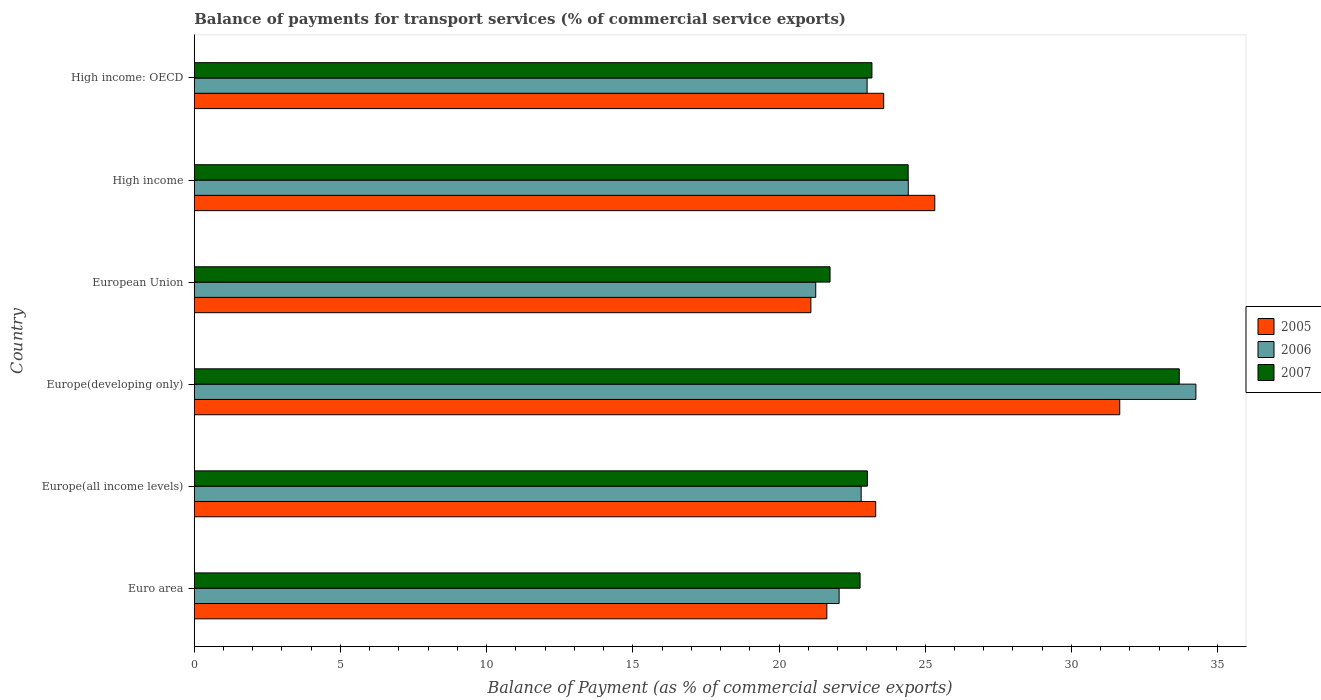How many different coloured bars are there?
Make the answer very short. 3. How many bars are there on the 4th tick from the bottom?
Offer a terse response. 3. What is the balance of payments for transport services in 2006 in High income: OECD?
Provide a short and direct response. 23.01. Across all countries, what is the maximum balance of payments for transport services in 2005?
Your response must be concise. 31.65. Across all countries, what is the minimum balance of payments for transport services in 2005?
Ensure brevity in your answer.  21.09. In which country was the balance of payments for transport services in 2005 maximum?
Your answer should be very brief. Europe(developing only). In which country was the balance of payments for transport services in 2007 minimum?
Keep it short and to the point. European Union. What is the total balance of payments for transport services in 2005 in the graph?
Offer a very short reply. 146.59. What is the difference between the balance of payments for transport services in 2006 in Euro area and that in High income?
Provide a short and direct response. -2.37. What is the difference between the balance of payments for transport services in 2006 in Euro area and the balance of payments for transport services in 2007 in Europe(all income levels)?
Offer a very short reply. -0.97. What is the average balance of payments for transport services in 2007 per country?
Keep it short and to the point. 24.8. What is the difference between the balance of payments for transport services in 2005 and balance of payments for transport services in 2006 in European Union?
Provide a short and direct response. -0.17. What is the ratio of the balance of payments for transport services in 2006 in Europe(all income levels) to that in High income?
Keep it short and to the point. 0.93. Is the balance of payments for transport services in 2005 in Europe(developing only) less than that in European Union?
Offer a very short reply. No. Is the difference between the balance of payments for transport services in 2005 in European Union and High income: OECD greater than the difference between the balance of payments for transport services in 2006 in European Union and High income: OECD?
Your answer should be compact. No. What is the difference between the highest and the second highest balance of payments for transport services in 2007?
Give a very brief answer. 9.27. What is the difference between the highest and the lowest balance of payments for transport services in 2006?
Offer a terse response. 13. Is the sum of the balance of payments for transport services in 2007 in Europe(all income levels) and High income greater than the maximum balance of payments for transport services in 2006 across all countries?
Your answer should be very brief. Yes. What does the 2nd bar from the top in High income represents?
Offer a terse response. 2006. What does the 1st bar from the bottom in European Union represents?
Provide a succinct answer. 2005. Is it the case that in every country, the sum of the balance of payments for transport services in 2006 and balance of payments for transport services in 2007 is greater than the balance of payments for transport services in 2005?
Offer a very short reply. Yes. How many bars are there?
Offer a very short reply. 18. How many countries are there in the graph?
Offer a terse response. 6. Does the graph contain grids?
Your answer should be very brief. No. Where does the legend appear in the graph?
Offer a terse response. Center right. What is the title of the graph?
Offer a very short reply. Balance of payments for transport services (% of commercial service exports). What is the label or title of the X-axis?
Make the answer very short. Balance of Payment (as % of commercial service exports). What is the Balance of Payment (as % of commercial service exports) of 2005 in Euro area?
Your answer should be very brief. 21.64. What is the Balance of Payment (as % of commercial service exports) of 2006 in Euro area?
Keep it short and to the point. 22.06. What is the Balance of Payment (as % of commercial service exports) in 2007 in Euro area?
Give a very brief answer. 22.77. What is the Balance of Payment (as % of commercial service exports) of 2005 in Europe(all income levels)?
Make the answer very short. 23.31. What is the Balance of Payment (as % of commercial service exports) of 2006 in Europe(all income levels)?
Make the answer very short. 22.81. What is the Balance of Payment (as % of commercial service exports) of 2007 in Europe(all income levels)?
Your answer should be compact. 23.02. What is the Balance of Payment (as % of commercial service exports) of 2005 in Europe(developing only)?
Offer a terse response. 31.65. What is the Balance of Payment (as % of commercial service exports) of 2006 in Europe(developing only)?
Provide a succinct answer. 34.26. What is the Balance of Payment (as % of commercial service exports) in 2007 in Europe(developing only)?
Ensure brevity in your answer.  33.69. What is the Balance of Payment (as % of commercial service exports) of 2005 in European Union?
Ensure brevity in your answer.  21.09. What is the Balance of Payment (as % of commercial service exports) of 2006 in European Union?
Give a very brief answer. 21.25. What is the Balance of Payment (as % of commercial service exports) in 2007 in European Union?
Provide a short and direct response. 21.74. What is the Balance of Payment (as % of commercial service exports) of 2005 in High income?
Your response must be concise. 25.33. What is the Balance of Payment (as % of commercial service exports) of 2006 in High income?
Provide a succinct answer. 24.42. What is the Balance of Payment (as % of commercial service exports) of 2007 in High income?
Give a very brief answer. 24.42. What is the Balance of Payment (as % of commercial service exports) of 2005 in High income: OECD?
Keep it short and to the point. 23.58. What is the Balance of Payment (as % of commercial service exports) of 2006 in High income: OECD?
Keep it short and to the point. 23.01. What is the Balance of Payment (as % of commercial service exports) of 2007 in High income: OECD?
Your answer should be very brief. 23.18. Across all countries, what is the maximum Balance of Payment (as % of commercial service exports) of 2005?
Ensure brevity in your answer.  31.65. Across all countries, what is the maximum Balance of Payment (as % of commercial service exports) in 2006?
Your answer should be compact. 34.26. Across all countries, what is the maximum Balance of Payment (as % of commercial service exports) of 2007?
Offer a terse response. 33.69. Across all countries, what is the minimum Balance of Payment (as % of commercial service exports) of 2005?
Make the answer very short. 21.09. Across all countries, what is the minimum Balance of Payment (as % of commercial service exports) of 2006?
Give a very brief answer. 21.25. Across all countries, what is the minimum Balance of Payment (as % of commercial service exports) of 2007?
Make the answer very short. 21.74. What is the total Balance of Payment (as % of commercial service exports) of 2005 in the graph?
Your answer should be compact. 146.59. What is the total Balance of Payment (as % of commercial service exports) of 2006 in the graph?
Your response must be concise. 147.81. What is the total Balance of Payment (as % of commercial service exports) in 2007 in the graph?
Ensure brevity in your answer.  148.82. What is the difference between the Balance of Payment (as % of commercial service exports) of 2005 in Euro area and that in Europe(all income levels)?
Ensure brevity in your answer.  -1.67. What is the difference between the Balance of Payment (as % of commercial service exports) in 2006 in Euro area and that in Europe(all income levels)?
Provide a short and direct response. -0.75. What is the difference between the Balance of Payment (as % of commercial service exports) of 2007 in Euro area and that in Europe(all income levels)?
Your response must be concise. -0.25. What is the difference between the Balance of Payment (as % of commercial service exports) in 2005 in Euro area and that in Europe(developing only)?
Your answer should be very brief. -10.02. What is the difference between the Balance of Payment (as % of commercial service exports) of 2006 in Euro area and that in Europe(developing only)?
Provide a succinct answer. -12.2. What is the difference between the Balance of Payment (as % of commercial service exports) of 2007 in Euro area and that in Europe(developing only)?
Offer a very short reply. -10.92. What is the difference between the Balance of Payment (as % of commercial service exports) in 2005 in Euro area and that in European Union?
Provide a short and direct response. 0.55. What is the difference between the Balance of Payment (as % of commercial service exports) in 2006 in Euro area and that in European Union?
Give a very brief answer. 0.8. What is the difference between the Balance of Payment (as % of commercial service exports) in 2007 in Euro area and that in European Union?
Provide a short and direct response. 1.03. What is the difference between the Balance of Payment (as % of commercial service exports) in 2005 in Euro area and that in High income?
Give a very brief answer. -3.69. What is the difference between the Balance of Payment (as % of commercial service exports) in 2006 in Euro area and that in High income?
Provide a succinct answer. -2.37. What is the difference between the Balance of Payment (as % of commercial service exports) in 2007 in Euro area and that in High income?
Your response must be concise. -1.65. What is the difference between the Balance of Payment (as % of commercial service exports) in 2005 in Euro area and that in High income: OECD?
Make the answer very short. -1.94. What is the difference between the Balance of Payment (as % of commercial service exports) in 2006 in Euro area and that in High income: OECD?
Keep it short and to the point. -0.96. What is the difference between the Balance of Payment (as % of commercial service exports) in 2007 in Euro area and that in High income: OECD?
Your answer should be very brief. -0.41. What is the difference between the Balance of Payment (as % of commercial service exports) in 2005 in Europe(all income levels) and that in Europe(developing only)?
Make the answer very short. -8.35. What is the difference between the Balance of Payment (as % of commercial service exports) of 2006 in Europe(all income levels) and that in Europe(developing only)?
Keep it short and to the point. -11.45. What is the difference between the Balance of Payment (as % of commercial service exports) of 2007 in Europe(all income levels) and that in Europe(developing only)?
Your response must be concise. -10.67. What is the difference between the Balance of Payment (as % of commercial service exports) of 2005 in Europe(all income levels) and that in European Union?
Ensure brevity in your answer.  2.22. What is the difference between the Balance of Payment (as % of commercial service exports) of 2006 in Europe(all income levels) and that in European Union?
Ensure brevity in your answer.  1.55. What is the difference between the Balance of Payment (as % of commercial service exports) of 2007 in Europe(all income levels) and that in European Union?
Give a very brief answer. 1.28. What is the difference between the Balance of Payment (as % of commercial service exports) in 2005 in Europe(all income levels) and that in High income?
Ensure brevity in your answer.  -2.02. What is the difference between the Balance of Payment (as % of commercial service exports) in 2006 in Europe(all income levels) and that in High income?
Offer a terse response. -1.61. What is the difference between the Balance of Payment (as % of commercial service exports) of 2007 in Europe(all income levels) and that in High income?
Keep it short and to the point. -1.4. What is the difference between the Balance of Payment (as % of commercial service exports) of 2005 in Europe(all income levels) and that in High income: OECD?
Give a very brief answer. -0.27. What is the difference between the Balance of Payment (as % of commercial service exports) in 2006 in Europe(all income levels) and that in High income: OECD?
Offer a very short reply. -0.2. What is the difference between the Balance of Payment (as % of commercial service exports) of 2007 in Europe(all income levels) and that in High income: OECD?
Keep it short and to the point. -0.16. What is the difference between the Balance of Payment (as % of commercial service exports) in 2005 in Europe(developing only) and that in European Union?
Keep it short and to the point. 10.56. What is the difference between the Balance of Payment (as % of commercial service exports) of 2006 in Europe(developing only) and that in European Union?
Provide a succinct answer. 13. What is the difference between the Balance of Payment (as % of commercial service exports) in 2007 in Europe(developing only) and that in European Union?
Ensure brevity in your answer.  11.94. What is the difference between the Balance of Payment (as % of commercial service exports) in 2005 in Europe(developing only) and that in High income?
Make the answer very short. 6.33. What is the difference between the Balance of Payment (as % of commercial service exports) of 2006 in Europe(developing only) and that in High income?
Keep it short and to the point. 9.84. What is the difference between the Balance of Payment (as % of commercial service exports) of 2007 in Europe(developing only) and that in High income?
Give a very brief answer. 9.27. What is the difference between the Balance of Payment (as % of commercial service exports) in 2005 in Europe(developing only) and that in High income: OECD?
Make the answer very short. 8.07. What is the difference between the Balance of Payment (as % of commercial service exports) in 2006 in Europe(developing only) and that in High income: OECD?
Your answer should be very brief. 11.25. What is the difference between the Balance of Payment (as % of commercial service exports) of 2007 in Europe(developing only) and that in High income: OECD?
Offer a terse response. 10.51. What is the difference between the Balance of Payment (as % of commercial service exports) in 2005 in European Union and that in High income?
Offer a terse response. -4.24. What is the difference between the Balance of Payment (as % of commercial service exports) in 2006 in European Union and that in High income?
Your answer should be very brief. -3.17. What is the difference between the Balance of Payment (as % of commercial service exports) of 2007 in European Union and that in High income?
Your answer should be very brief. -2.67. What is the difference between the Balance of Payment (as % of commercial service exports) in 2005 in European Union and that in High income: OECD?
Give a very brief answer. -2.49. What is the difference between the Balance of Payment (as % of commercial service exports) of 2006 in European Union and that in High income: OECD?
Provide a succinct answer. -1.76. What is the difference between the Balance of Payment (as % of commercial service exports) in 2007 in European Union and that in High income: OECD?
Give a very brief answer. -1.43. What is the difference between the Balance of Payment (as % of commercial service exports) of 2005 in High income and that in High income: OECD?
Give a very brief answer. 1.75. What is the difference between the Balance of Payment (as % of commercial service exports) in 2006 in High income and that in High income: OECD?
Give a very brief answer. 1.41. What is the difference between the Balance of Payment (as % of commercial service exports) of 2007 in High income and that in High income: OECD?
Keep it short and to the point. 1.24. What is the difference between the Balance of Payment (as % of commercial service exports) in 2005 in Euro area and the Balance of Payment (as % of commercial service exports) in 2006 in Europe(all income levels)?
Ensure brevity in your answer.  -1.17. What is the difference between the Balance of Payment (as % of commercial service exports) of 2005 in Euro area and the Balance of Payment (as % of commercial service exports) of 2007 in Europe(all income levels)?
Keep it short and to the point. -1.39. What is the difference between the Balance of Payment (as % of commercial service exports) of 2006 in Euro area and the Balance of Payment (as % of commercial service exports) of 2007 in Europe(all income levels)?
Offer a terse response. -0.97. What is the difference between the Balance of Payment (as % of commercial service exports) in 2005 in Euro area and the Balance of Payment (as % of commercial service exports) in 2006 in Europe(developing only)?
Your response must be concise. -12.62. What is the difference between the Balance of Payment (as % of commercial service exports) in 2005 in Euro area and the Balance of Payment (as % of commercial service exports) in 2007 in Europe(developing only)?
Provide a succinct answer. -12.05. What is the difference between the Balance of Payment (as % of commercial service exports) in 2006 in Euro area and the Balance of Payment (as % of commercial service exports) in 2007 in Europe(developing only)?
Your answer should be very brief. -11.63. What is the difference between the Balance of Payment (as % of commercial service exports) of 2005 in Euro area and the Balance of Payment (as % of commercial service exports) of 2006 in European Union?
Keep it short and to the point. 0.38. What is the difference between the Balance of Payment (as % of commercial service exports) of 2005 in Euro area and the Balance of Payment (as % of commercial service exports) of 2007 in European Union?
Provide a short and direct response. -0.11. What is the difference between the Balance of Payment (as % of commercial service exports) of 2006 in Euro area and the Balance of Payment (as % of commercial service exports) of 2007 in European Union?
Keep it short and to the point. 0.31. What is the difference between the Balance of Payment (as % of commercial service exports) of 2005 in Euro area and the Balance of Payment (as % of commercial service exports) of 2006 in High income?
Provide a succinct answer. -2.79. What is the difference between the Balance of Payment (as % of commercial service exports) in 2005 in Euro area and the Balance of Payment (as % of commercial service exports) in 2007 in High income?
Provide a short and direct response. -2.78. What is the difference between the Balance of Payment (as % of commercial service exports) in 2006 in Euro area and the Balance of Payment (as % of commercial service exports) in 2007 in High income?
Provide a succinct answer. -2.36. What is the difference between the Balance of Payment (as % of commercial service exports) in 2005 in Euro area and the Balance of Payment (as % of commercial service exports) in 2006 in High income: OECD?
Your response must be concise. -1.38. What is the difference between the Balance of Payment (as % of commercial service exports) of 2005 in Euro area and the Balance of Payment (as % of commercial service exports) of 2007 in High income: OECD?
Give a very brief answer. -1.54. What is the difference between the Balance of Payment (as % of commercial service exports) of 2006 in Euro area and the Balance of Payment (as % of commercial service exports) of 2007 in High income: OECD?
Offer a terse response. -1.12. What is the difference between the Balance of Payment (as % of commercial service exports) in 2005 in Europe(all income levels) and the Balance of Payment (as % of commercial service exports) in 2006 in Europe(developing only)?
Offer a terse response. -10.95. What is the difference between the Balance of Payment (as % of commercial service exports) of 2005 in Europe(all income levels) and the Balance of Payment (as % of commercial service exports) of 2007 in Europe(developing only)?
Ensure brevity in your answer.  -10.38. What is the difference between the Balance of Payment (as % of commercial service exports) of 2006 in Europe(all income levels) and the Balance of Payment (as % of commercial service exports) of 2007 in Europe(developing only)?
Your answer should be very brief. -10.88. What is the difference between the Balance of Payment (as % of commercial service exports) of 2005 in Europe(all income levels) and the Balance of Payment (as % of commercial service exports) of 2006 in European Union?
Keep it short and to the point. 2.05. What is the difference between the Balance of Payment (as % of commercial service exports) of 2005 in Europe(all income levels) and the Balance of Payment (as % of commercial service exports) of 2007 in European Union?
Your answer should be compact. 1.56. What is the difference between the Balance of Payment (as % of commercial service exports) of 2006 in Europe(all income levels) and the Balance of Payment (as % of commercial service exports) of 2007 in European Union?
Ensure brevity in your answer.  1.06. What is the difference between the Balance of Payment (as % of commercial service exports) in 2005 in Europe(all income levels) and the Balance of Payment (as % of commercial service exports) in 2006 in High income?
Keep it short and to the point. -1.11. What is the difference between the Balance of Payment (as % of commercial service exports) in 2005 in Europe(all income levels) and the Balance of Payment (as % of commercial service exports) in 2007 in High income?
Offer a terse response. -1.11. What is the difference between the Balance of Payment (as % of commercial service exports) of 2006 in Europe(all income levels) and the Balance of Payment (as % of commercial service exports) of 2007 in High income?
Give a very brief answer. -1.61. What is the difference between the Balance of Payment (as % of commercial service exports) in 2005 in Europe(all income levels) and the Balance of Payment (as % of commercial service exports) in 2006 in High income: OECD?
Make the answer very short. 0.29. What is the difference between the Balance of Payment (as % of commercial service exports) of 2005 in Europe(all income levels) and the Balance of Payment (as % of commercial service exports) of 2007 in High income: OECD?
Give a very brief answer. 0.13. What is the difference between the Balance of Payment (as % of commercial service exports) in 2006 in Europe(all income levels) and the Balance of Payment (as % of commercial service exports) in 2007 in High income: OECD?
Provide a succinct answer. -0.37. What is the difference between the Balance of Payment (as % of commercial service exports) in 2005 in Europe(developing only) and the Balance of Payment (as % of commercial service exports) in 2006 in European Union?
Keep it short and to the point. 10.4. What is the difference between the Balance of Payment (as % of commercial service exports) of 2005 in Europe(developing only) and the Balance of Payment (as % of commercial service exports) of 2007 in European Union?
Your answer should be very brief. 9.91. What is the difference between the Balance of Payment (as % of commercial service exports) in 2006 in Europe(developing only) and the Balance of Payment (as % of commercial service exports) in 2007 in European Union?
Your answer should be very brief. 12.51. What is the difference between the Balance of Payment (as % of commercial service exports) of 2005 in Europe(developing only) and the Balance of Payment (as % of commercial service exports) of 2006 in High income?
Ensure brevity in your answer.  7.23. What is the difference between the Balance of Payment (as % of commercial service exports) in 2005 in Europe(developing only) and the Balance of Payment (as % of commercial service exports) in 2007 in High income?
Your answer should be very brief. 7.24. What is the difference between the Balance of Payment (as % of commercial service exports) of 2006 in Europe(developing only) and the Balance of Payment (as % of commercial service exports) of 2007 in High income?
Offer a very short reply. 9.84. What is the difference between the Balance of Payment (as % of commercial service exports) in 2005 in Europe(developing only) and the Balance of Payment (as % of commercial service exports) in 2006 in High income: OECD?
Give a very brief answer. 8.64. What is the difference between the Balance of Payment (as % of commercial service exports) of 2005 in Europe(developing only) and the Balance of Payment (as % of commercial service exports) of 2007 in High income: OECD?
Provide a short and direct response. 8.48. What is the difference between the Balance of Payment (as % of commercial service exports) of 2006 in Europe(developing only) and the Balance of Payment (as % of commercial service exports) of 2007 in High income: OECD?
Provide a short and direct response. 11.08. What is the difference between the Balance of Payment (as % of commercial service exports) in 2005 in European Union and the Balance of Payment (as % of commercial service exports) in 2006 in High income?
Give a very brief answer. -3.33. What is the difference between the Balance of Payment (as % of commercial service exports) in 2005 in European Union and the Balance of Payment (as % of commercial service exports) in 2007 in High income?
Provide a short and direct response. -3.33. What is the difference between the Balance of Payment (as % of commercial service exports) of 2006 in European Union and the Balance of Payment (as % of commercial service exports) of 2007 in High income?
Your response must be concise. -3.16. What is the difference between the Balance of Payment (as % of commercial service exports) in 2005 in European Union and the Balance of Payment (as % of commercial service exports) in 2006 in High income: OECD?
Make the answer very short. -1.92. What is the difference between the Balance of Payment (as % of commercial service exports) in 2005 in European Union and the Balance of Payment (as % of commercial service exports) in 2007 in High income: OECD?
Keep it short and to the point. -2.09. What is the difference between the Balance of Payment (as % of commercial service exports) of 2006 in European Union and the Balance of Payment (as % of commercial service exports) of 2007 in High income: OECD?
Keep it short and to the point. -1.92. What is the difference between the Balance of Payment (as % of commercial service exports) of 2005 in High income and the Balance of Payment (as % of commercial service exports) of 2006 in High income: OECD?
Offer a very short reply. 2.31. What is the difference between the Balance of Payment (as % of commercial service exports) of 2005 in High income and the Balance of Payment (as % of commercial service exports) of 2007 in High income: OECD?
Your answer should be compact. 2.15. What is the difference between the Balance of Payment (as % of commercial service exports) in 2006 in High income and the Balance of Payment (as % of commercial service exports) in 2007 in High income: OECD?
Ensure brevity in your answer.  1.24. What is the average Balance of Payment (as % of commercial service exports) of 2005 per country?
Give a very brief answer. 24.43. What is the average Balance of Payment (as % of commercial service exports) of 2006 per country?
Provide a succinct answer. 24.63. What is the average Balance of Payment (as % of commercial service exports) in 2007 per country?
Your response must be concise. 24.8. What is the difference between the Balance of Payment (as % of commercial service exports) of 2005 and Balance of Payment (as % of commercial service exports) of 2006 in Euro area?
Provide a succinct answer. -0.42. What is the difference between the Balance of Payment (as % of commercial service exports) of 2005 and Balance of Payment (as % of commercial service exports) of 2007 in Euro area?
Offer a very short reply. -1.14. What is the difference between the Balance of Payment (as % of commercial service exports) of 2006 and Balance of Payment (as % of commercial service exports) of 2007 in Euro area?
Provide a succinct answer. -0.72. What is the difference between the Balance of Payment (as % of commercial service exports) in 2005 and Balance of Payment (as % of commercial service exports) in 2006 in Europe(all income levels)?
Your answer should be compact. 0.5. What is the difference between the Balance of Payment (as % of commercial service exports) in 2005 and Balance of Payment (as % of commercial service exports) in 2007 in Europe(all income levels)?
Ensure brevity in your answer.  0.29. What is the difference between the Balance of Payment (as % of commercial service exports) in 2006 and Balance of Payment (as % of commercial service exports) in 2007 in Europe(all income levels)?
Your answer should be very brief. -0.21. What is the difference between the Balance of Payment (as % of commercial service exports) in 2005 and Balance of Payment (as % of commercial service exports) in 2006 in Europe(developing only)?
Make the answer very short. -2.6. What is the difference between the Balance of Payment (as % of commercial service exports) in 2005 and Balance of Payment (as % of commercial service exports) in 2007 in Europe(developing only)?
Offer a very short reply. -2.04. What is the difference between the Balance of Payment (as % of commercial service exports) in 2006 and Balance of Payment (as % of commercial service exports) in 2007 in Europe(developing only)?
Your answer should be compact. 0.57. What is the difference between the Balance of Payment (as % of commercial service exports) in 2005 and Balance of Payment (as % of commercial service exports) in 2006 in European Union?
Provide a short and direct response. -0.17. What is the difference between the Balance of Payment (as % of commercial service exports) of 2005 and Balance of Payment (as % of commercial service exports) of 2007 in European Union?
Your answer should be very brief. -0.66. What is the difference between the Balance of Payment (as % of commercial service exports) of 2006 and Balance of Payment (as % of commercial service exports) of 2007 in European Union?
Provide a succinct answer. -0.49. What is the difference between the Balance of Payment (as % of commercial service exports) in 2005 and Balance of Payment (as % of commercial service exports) in 2006 in High income?
Keep it short and to the point. 0.91. What is the difference between the Balance of Payment (as % of commercial service exports) of 2005 and Balance of Payment (as % of commercial service exports) of 2007 in High income?
Your response must be concise. 0.91. What is the difference between the Balance of Payment (as % of commercial service exports) of 2006 and Balance of Payment (as % of commercial service exports) of 2007 in High income?
Your answer should be compact. 0. What is the difference between the Balance of Payment (as % of commercial service exports) of 2005 and Balance of Payment (as % of commercial service exports) of 2006 in High income: OECD?
Your response must be concise. 0.57. What is the difference between the Balance of Payment (as % of commercial service exports) in 2005 and Balance of Payment (as % of commercial service exports) in 2007 in High income: OECD?
Keep it short and to the point. 0.4. What is the difference between the Balance of Payment (as % of commercial service exports) in 2006 and Balance of Payment (as % of commercial service exports) in 2007 in High income: OECD?
Provide a succinct answer. -0.17. What is the ratio of the Balance of Payment (as % of commercial service exports) of 2005 in Euro area to that in Europe(all income levels)?
Ensure brevity in your answer.  0.93. What is the ratio of the Balance of Payment (as % of commercial service exports) of 2006 in Euro area to that in Europe(all income levels)?
Provide a short and direct response. 0.97. What is the ratio of the Balance of Payment (as % of commercial service exports) in 2007 in Euro area to that in Europe(all income levels)?
Provide a succinct answer. 0.99. What is the ratio of the Balance of Payment (as % of commercial service exports) in 2005 in Euro area to that in Europe(developing only)?
Provide a short and direct response. 0.68. What is the ratio of the Balance of Payment (as % of commercial service exports) of 2006 in Euro area to that in Europe(developing only)?
Provide a succinct answer. 0.64. What is the ratio of the Balance of Payment (as % of commercial service exports) of 2007 in Euro area to that in Europe(developing only)?
Give a very brief answer. 0.68. What is the ratio of the Balance of Payment (as % of commercial service exports) of 2005 in Euro area to that in European Union?
Provide a succinct answer. 1.03. What is the ratio of the Balance of Payment (as % of commercial service exports) of 2006 in Euro area to that in European Union?
Your response must be concise. 1.04. What is the ratio of the Balance of Payment (as % of commercial service exports) of 2007 in Euro area to that in European Union?
Give a very brief answer. 1.05. What is the ratio of the Balance of Payment (as % of commercial service exports) in 2005 in Euro area to that in High income?
Your answer should be compact. 0.85. What is the ratio of the Balance of Payment (as % of commercial service exports) in 2006 in Euro area to that in High income?
Keep it short and to the point. 0.9. What is the ratio of the Balance of Payment (as % of commercial service exports) of 2007 in Euro area to that in High income?
Your answer should be compact. 0.93. What is the ratio of the Balance of Payment (as % of commercial service exports) of 2005 in Euro area to that in High income: OECD?
Offer a terse response. 0.92. What is the ratio of the Balance of Payment (as % of commercial service exports) of 2006 in Euro area to that in High income: OECD?
Ensure brevity in your answer.  0.96. What is the ratio of the Balance of Payment (as % of commercial service exports) of 2007 in Euro area to that in High income: OECD?
Provide a succinct answer. 0.98. What is the ratio of the Balance of Payment (as % of commercial service exports) in 2005 in Europe(all income levels) to that in Europe(developing only)?
Offer a terse response. 0.74. What is the ratio of the Balance of Payment (as % of commercial service exports) in 2006 in Europe(all income levels) to that in Europe(developing only)?
Offer a very short reply. 0.67. What is the ratio of the Balance of Payment (as % of commercial service exports) of 2007 in Europe(all income levels) to that in Europe(developing only)?
Your answer should be compact. 0.68. What is the ratio of the Balance of Payment (as % of commercial service exports) of 2005 in Europe(all income levels) to that in European Union?
Offer a terse response. 1.11. What is the ratio of the Balance of Payment (as % of commercial service exports) of 2006 in Europe(all income levels) to that in European Union?
Keep it short and to the point. 1.07. What is the ratio of the Balance of Payment (as % of commercial service exports) in 2007 in Europe(all income levels) to that in European Union?
Your answer should be very brief. 1.06. What is the ratio of the Balance of Payment (as % of commercial service exports) of 2005 in Europe(all income levels) to that in High income?
Keep it short and to the point. 0.92. What is the ratio of the Balance of Payment (as % of commercial service exports) of 2006 in Europe(all income levels) to that in High income?
Provide a succinct answer. 0.93. What is the ratio of the Balance of Payment (as % of commercial service exports) of 2007 in Europe(all income levels) to that in High income?
Provide a short and direct response. 0.94. What is the ratio of the Balance of Payment (as % of commercial service exports) in 2005 in Europe(all income levels) to that in High income: OECD?
Give a very brief answer. 0.99. What is the ratio of the Balance of Payment (as % of commercial service exports) in 2005 in Europe(developing only) to that in European Union?
Your answer should be compact. 1.5. What is the ratio of the Balance of Payment (as % of commercial service exports) in 2006 in Europe(developing only) to that in European Union?
Offer a very short reply. 1.61. What is the ratio of the Balance of Payment (as % of commercial service exports) of 2007 in Europe(developing only) to that in European Union?
Your answer should be very brief. 1.55. What is the ratio of the Balance of Payment (as % of commercial service exports) of 2005 in Europe(developing only) to that in High income?
Ensure brevity in your answer.  1.25. What is the ratio of the Balance of Payment (as % of commercial service exports) in 2006 in Europe(developing only) to that in High income?
Your answer should be very brief. 1.4. What is the ratio of the Balance of Payment (as % of commercial service exports) in 2007 in Europe(developing only) to that in High income?
Provide a succinct answer. 1.38. What is the ratio of the Balance of Payment (as % of commercial service exports) of 2005 in Europe(developing only) to that in High income: OECD?
Offer a very short reply. 1.34. What is the ratio of the Balance of Payment (as % of commercial service exports) in 2006 in Europe(developing only) to that in High income: OECD?
Provide a short and direct response. 1.49. What is the ratio of the Balance of Payment (as % of commercial service exports) in 2007 in Europe(developing only) to that in High income: OECD?
Your answer should be very brief. 1.45. What is the ratio of the Balance of Payment (as % of commercial service exports) in 2005 in European Union to that in High income?
Provide a succinct answer. 0.83. What is the ratio of the Balance of Payment (as % of commercial service exports) of 2006 in European Union to that in High income?
Provide a short and direct response. 0.87. What is the ratio of the Balance of Payment (as % of commercial service exports) of 2007 in European Union to that in High income?
Offer a very short reply. 0.89. What is the ratio of the Balance of Payment (as % of commercial service exports) in 2005 in European Union to that in High income: OECD?
Ensure brevity in your answer.  0.89. What is the ratio of the Balance of Payment (as % of commercial service exports) in 2006 in European Union to that in High income: OECD?
Make the answer very short. 0.92. What is the ratio of the Balance of Payment (as % of commercial service exports) of 2007 in European Union to that in High income: OECD?
Give a very brief answer. 0.94. What is the ratio of the Balance of Payment (as % of commercial service exports) in 2005 in High income to that in High income: OECD?
Give a very brief answer. 1.07. What is the ratio of the Balance of Payment (as % of commercial service exports) of 2006 in High income to that in High income: OECD?
Make the answer very short. 1.06. What is the ratio of the Balance of Payment (as % of commercial service exports) of 2007 in High income to that in High income: OECD?
Offer a terse response. 1.05. What is the difference between the highest and the second highest Balance of Payment (as % of commercial service exports) of 2005?
Your response must be concise. 6.33. What is the difference between the highest and the second highest Balance of Payment (as % of commercial service exports) in 2006?
Give a very brief answer. 9.84. What is the difference between the highest and the second highest Balance of Payment (as % of commercial service exports) in 2007?
Your answer should be very brief. 9.27. What is the difference between the highest and the lowest Balance of Payment (as % of commercial service exports) in 2005?
Make the answer very short. 10.56. What is the difference between the highest and the lowest Balance of Payment (as % of commercial service exports) in 2006?
Your answer should be very brief. 13. What is the difference between the highest and the lowest Balance of Payment (as % of commercial service exports) in 2007?
Your response must be concise. 11.94. 